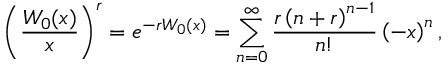Convert formula to latex. <formula><loc_0><loc_0><loc_500><loc_500>\left ( { \frac { W _ { 0 } ( x ) } { x } } \right ) ^ { r } = e ^ { - r W _ { 0 } ( x ) } = \sum _ { n = 0 } ^ { \infty } { \frac { r \left ( n + r \right ) ^ { n - 1 } } { n ! } } \left ( - x \right ) ^ { n } ,</formula> 